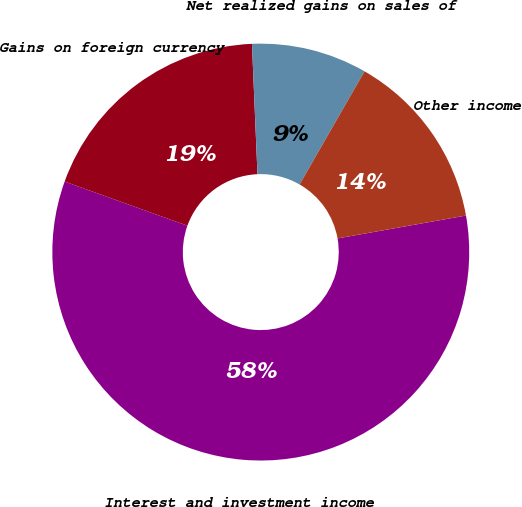<chart> <loc_0><loc_0><loc_500><loc_500><pie_chart><fcel>Interest and investment income<fcel>Gains on foreign currency<fcel>Net realized gains on sales of<fcel>Other income<nl><fcel>58.3%<fcel>18.83%<fcel>8.97%<fcel>13.9%<nl></chart> 